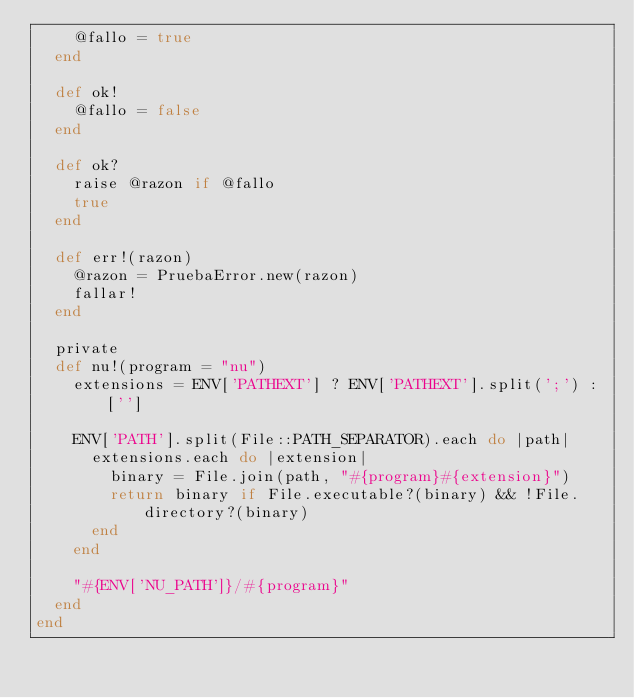Convert code to text. <code><loc_0><loc_0><loc_500><loc_500><_Ruby_>    @fallo = true
  end
    
  def ok!
    @fallo = false
  end
    
  def ok?
    raise @razon if @fallo
    true
  end
    
  def err!(razon)
    @razon = PruebaError.new(razon)
    fallar!
  end

  private
  def nu!(program = "nu")
    extensions = ENV['PATHEXT'] ? ENV['PATHEXT'].split(';') : ['']
  
    ENV['PATH'].split(File::PATH_SEPARATOR).each do |path|
      extensions.each do |extension|
        binary = File.join(path, "#{program}#{extension}")
        return binary if File.executable?(binary) && !File.directory?(binary)
      end
    end

    "#{ENV['NU_PATH']}/#{program}"
  end
end
</code> 